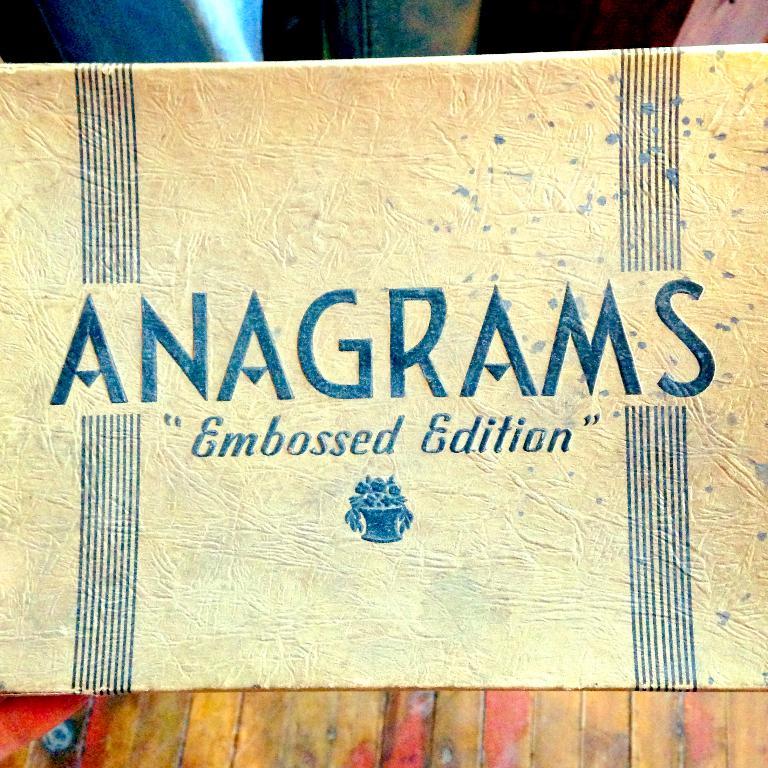Is this a board game?
Your response must be concise. Yes. What edition is this?
Provide a succinct answer. Embossed. 